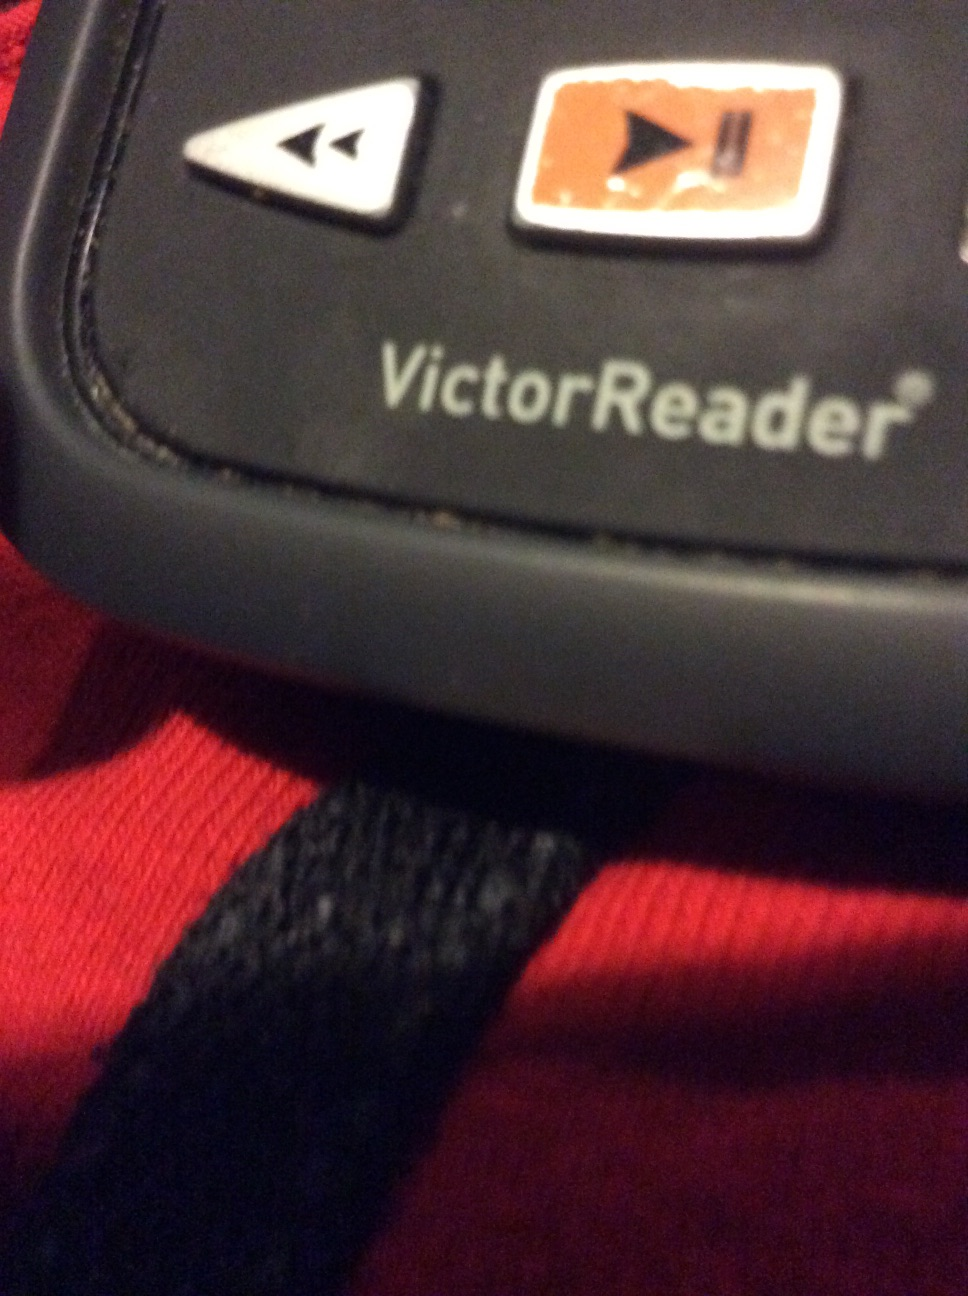Please describe a realistic scenario where this device could significantly improve someone's life in a short response. A visually impaired student using the VictorReader to navigate through their textbooks independently, helping them keep up with their studies. 